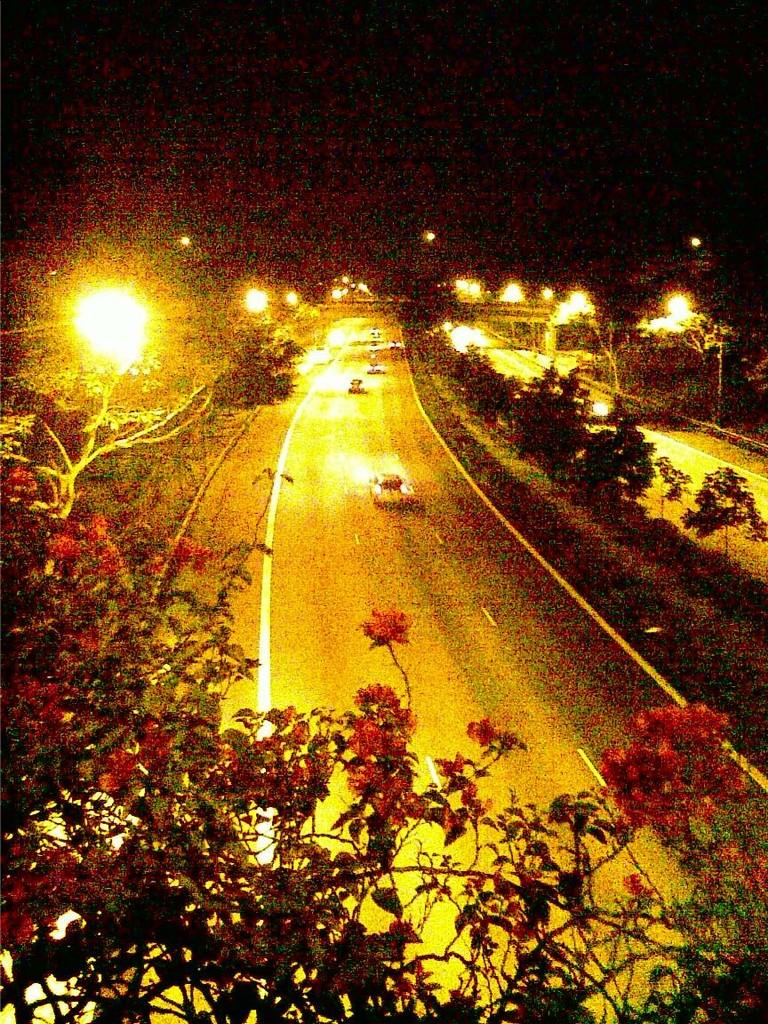What type of natural element can be seen in the image? There is a tree in the image. What else can be seen in the image besides the tree? There are vehicles on the road in the image. What time of day is depicted in the image? It is nighttime in the image. What type of pain can be seen on the faces of the people in the image? There are no people present in the image, so it is not possible to determine if they are experiencing any pain. 